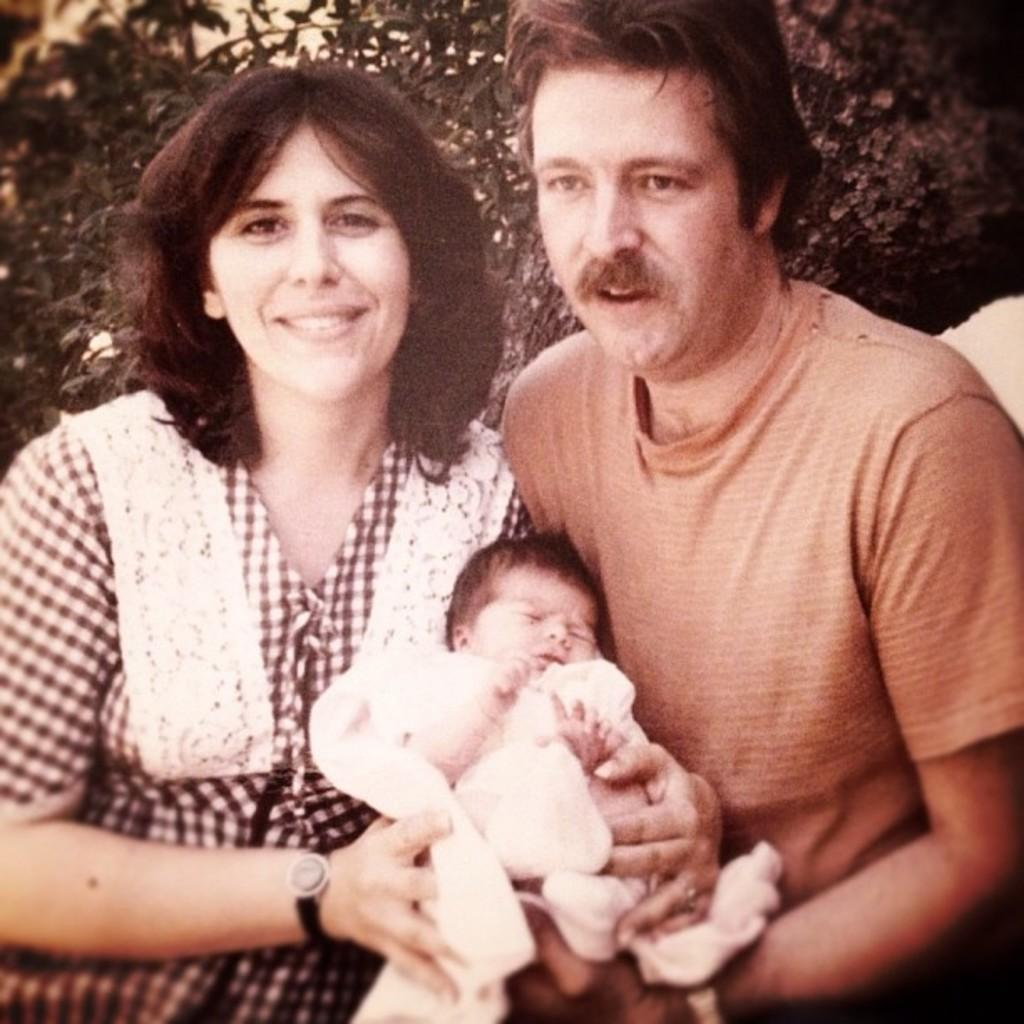How many people are in the image? There are two people in the image. What are the two people doing in the image? The two people are holding a baby. How does the baby appear in the image? The baby is smiling. What can be seen in the background of the image? There is a tree visible in the background of the image. What type of tramp is visible in the image? There is no tramp present in the image. What kind of operation is being performed on the baby in the image? There is no operation being performed on the baby in the image; the baby is simply being held by the two people. 